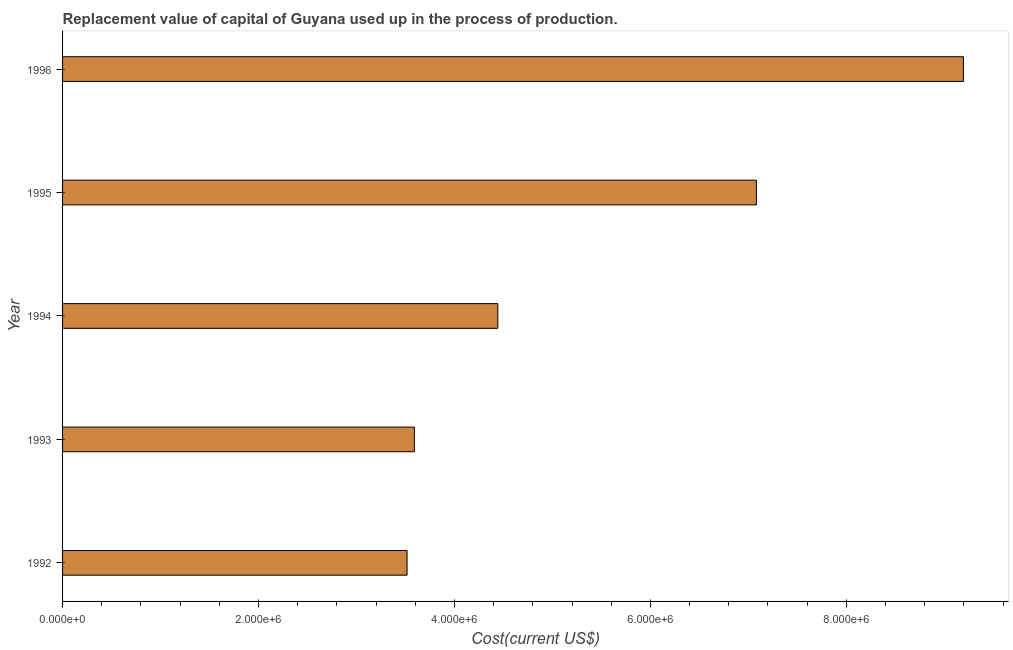What is the title of the graph?
Provide a succinct answer. Replacement value of capital of Guyana used up in the process of production. What is the label or title of the X-axis?
Provide a short and direct response. Cost(current US$). What is the consumption of fixed capital in 1994?
Offer a terse response. 4.44e+06. Across all years, what is the maximum consumption of fixed capital?
Keep it short and to the point. 9.20e+06. Across all years, what is the minimum consumption of fixed capital?
Provide a short and direct response. 3.52e+06. In which year was the consumption of fixed capital minimum?
Ensure brevity in your answer.  1992. What is the sum of the consumption of fixed capital?
Give a very brief answer. 2.78e+07. What is the difference between the consumption of fixed capital in 1993 and 1996?
Keep it short and to the point. -5.60e+06. What is the average consumption of fixed capital per year?
Your answer should be compact. 5.57e+06. What is the median consumption of fixed capital?
Make the answer very short. 4.44e+06. In how many years, is the consumption of fixed capital greater than 3200000 US$?
Offer a terse response. 5. Do a majority of the years between 1995 and 1994 (inclusive) have consumption of fixed capital greater than 4000000 US$?
Keep it short and to the point. No. What is the ratio of the consumption of fixed capital in 1992 to that in 1995?
Provide a short and direct response. 0.5. Is the consumption of fixed capital in 1993 less than that in 1994?
Your response must be concise. Yes. Is the difference between the consumption of fixed capital in 1992 and 1995 greater than the difference between any two years?
Your answer should be compact. No. What is the difference between the highest and the second highest consumption of fixed capital?
Ensure brevity in your answer.  2.11e+06. Is the sum of the consumption of fixed capital in 1994 and 1995 greater than the maximum consumption of fixed capital across all years?
Give a very brief answer. Yes. What is the difference between the highest and the lowest consumption of fixed capital?
Ensure brevity in your answer.  5.68e+06. In how many years, is the consumption of fixed capital greater than the average consumption of fixed capital taken over all years?
Offer a very short reply. 2. What is the Cost(current US$) of 1992?
Your response must be concise. 3.52e+06. What is the Cost(current US$) in 1993?
Provide a succinct answer. 3.59e+06. What is the Cost(current US$) of 1994?
Offer a terse response. 4.44e+06. What is the Cost(current US$) in 1995?
Ensure brevity in your answer.  7.08e+06. What is the Cost(current US$) of 1996?
Your response must be concise. 9.20e+06. What is the difference between the Cost(current US$) in 1992 and 1993?
Keep it short and to the point. -7.45e+04. What is the difference between the Cost(current US$) in 1992 and 1994?
Offer a terse response. -9.26e+05. What is the difference between the Cost(current US$) in 1992 and 1995?
Provide a short and direct response. -3.57e+06. What is the difference between the Cost(current US$) in 1992 and 1996?
Make the answer very short. -5.68e+06. What is the difference between the Cost(current US$) in 1993 and 1994?
Your answer should be very brief. -8.52e+05. What is the difference between the Cost(current US$) in 1993 and 1995?
Give a very brief answer. -3.49e+06. What is the difference between the Cost(current US$) in 1993 and 1996?
Make the answer very short. -5.60e+06. What is the difference between the Cost(current US$) in 1994 and 1995?
Offer a terse response. -2.64e+06. What is the difference between the Cost(current US$) in 1994 and 1996?
Provide a short and direct response. -4.75e+06. What is the difference between the Cost(current US$) in 1995 and 1996?
Give a very brief answer. -2.11e+06. What is the ratio of the Cost(current US$) in 1992 to that in 1994?
Provide a short and direct response. 0.79. What is the ratio of the Cost(current US$) in 1992 to that in 1995?
Offer a very short reply. 0.5. What is the ratio of the Cost(current US$) in 1992 to that in 1996?
Make the answer very short. 0.38. What is the ratio of the Cost(current US$) in 1993 to that in 1994?
Make the answer very short. 0.81. What is the ratio of the Cost(current US$) in 1993 to that in 1995?
Offer a very short reply. 0.51. What is the ratio of the Cost(current US$) in 1993 to that in 1996?
Give a very brief answer. 0.39. What is the ratio of the Cost(current US$) in 1994 to that in 1995?
Provide a succinct answer. 0.63. What is the ratio of the Cost(current US$) in 1994 to that in 1996?
Your answer should be compact. 0.48. What is the ratio of the Cost(current US$) in 1995 to that in 1996?
Provide a short and direct response. 0.77. 